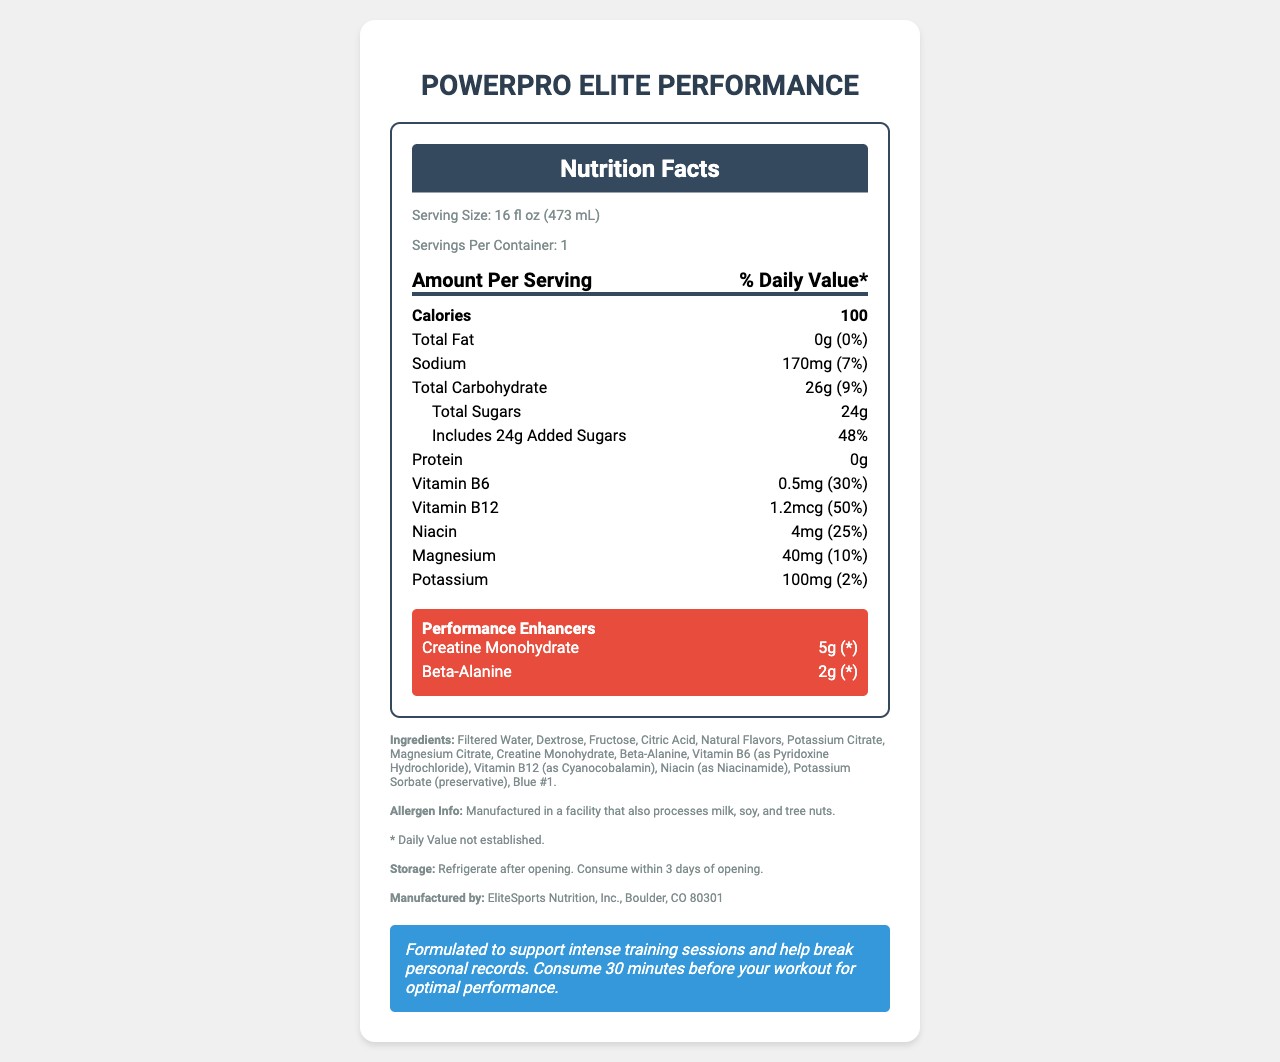what is the serving size for PowerPro Elite Performance? The serving size is clearly stated as "16 fl oz (473 mL)" under the "Serving Size" section.
Answer: 16 fl oz (473 mL) how many calories are in one serving of this drink? The "Calories" section explicitly mentions 100 calories per serving.
Answer: 100 what is the total carbohydrate content in this sports drink? The "Total Carbohydrate" section shows the amount as "26g".
Answer: 26g what is the amount of sodium in one serving? The "Sodium" section indicates that there are 170mg of sodium per serving.
Answer: 170mg what performance enhancers are included in this drink? The "Performance Enhancers" section lists Creatine Monohydrate and Beta-Alanine as the included enhancers.
Answer: Creatine Monohydrate and Beta-Alanine what percentage of daily value does the added sugar in this drink constitute? The drink contains 24g of added sugars which is 48% of the daily value as stated in the document.
Answer: 48% what is the primary color additive included in the ingredients? The "Ingredients" section lists Blue #1 as the color additive.
Answer: Blue #1 which vitamin provides the highest daily value percentage? A. Vitamin B6 B. Vitamin B12 C. Niacin Vitamin B6: 30%, Vitamin B12: 50%, Niacin: 25%. Thus, Vitamin B12 provides the highest daily value percentage.
Answer: B what is the manufacturer's location? A. New York, NY B. Chicago, IL C. Boulder, CO The "Manufacturer" section states that the product is manufactured by EliteSports Nutrition, Inc., Boulder, CO 80301.
Answer: C is there any protein in this sports drink? true or false? The "Protein" section indicates that there is 0g of protein in the drink.
Answer: False what is the main takeaway from the athlete note? The athlete note advises athletes to consume the drink 30 minutes before workout sessions for optimal performance benefits.
Answer: Consume 30 minutes before your workout for optimal performance describe the entire document. The document provides comprehensive nutritional information and usage guidelines for the "PowerPro Elite Performance" sports drink.
Answer: The document is a detailed Nutrition Facts Label for the "PowerPro Elite Performance" sports drink. It includes serving size, calories, fat, sodium, carbohydrates, sugars, vitamins and minerals, performance enhancers, ingredients, allergen info, and storage instructions. The label also has a special note for athletes advising them to consume the drink 30 minutes before workouts for optimal performance. what is the exact concentration of creatine monohydrate per serving in the drink? The document does not provide information on the exact concentration, only the total amount per serving.
Answer: Cannot be determined how many servings are in one container? The "Servings Per Container" section states that there is 1 serving per container.
Answer: 1 